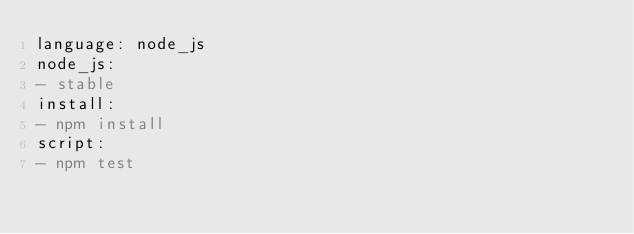Convert code to text. <code><loc_0><loc_0><loc_500><loc_500><_YAML_>language: node_js
node_js:
- stable
install:
- npm install
script:
- npm test

</code> 